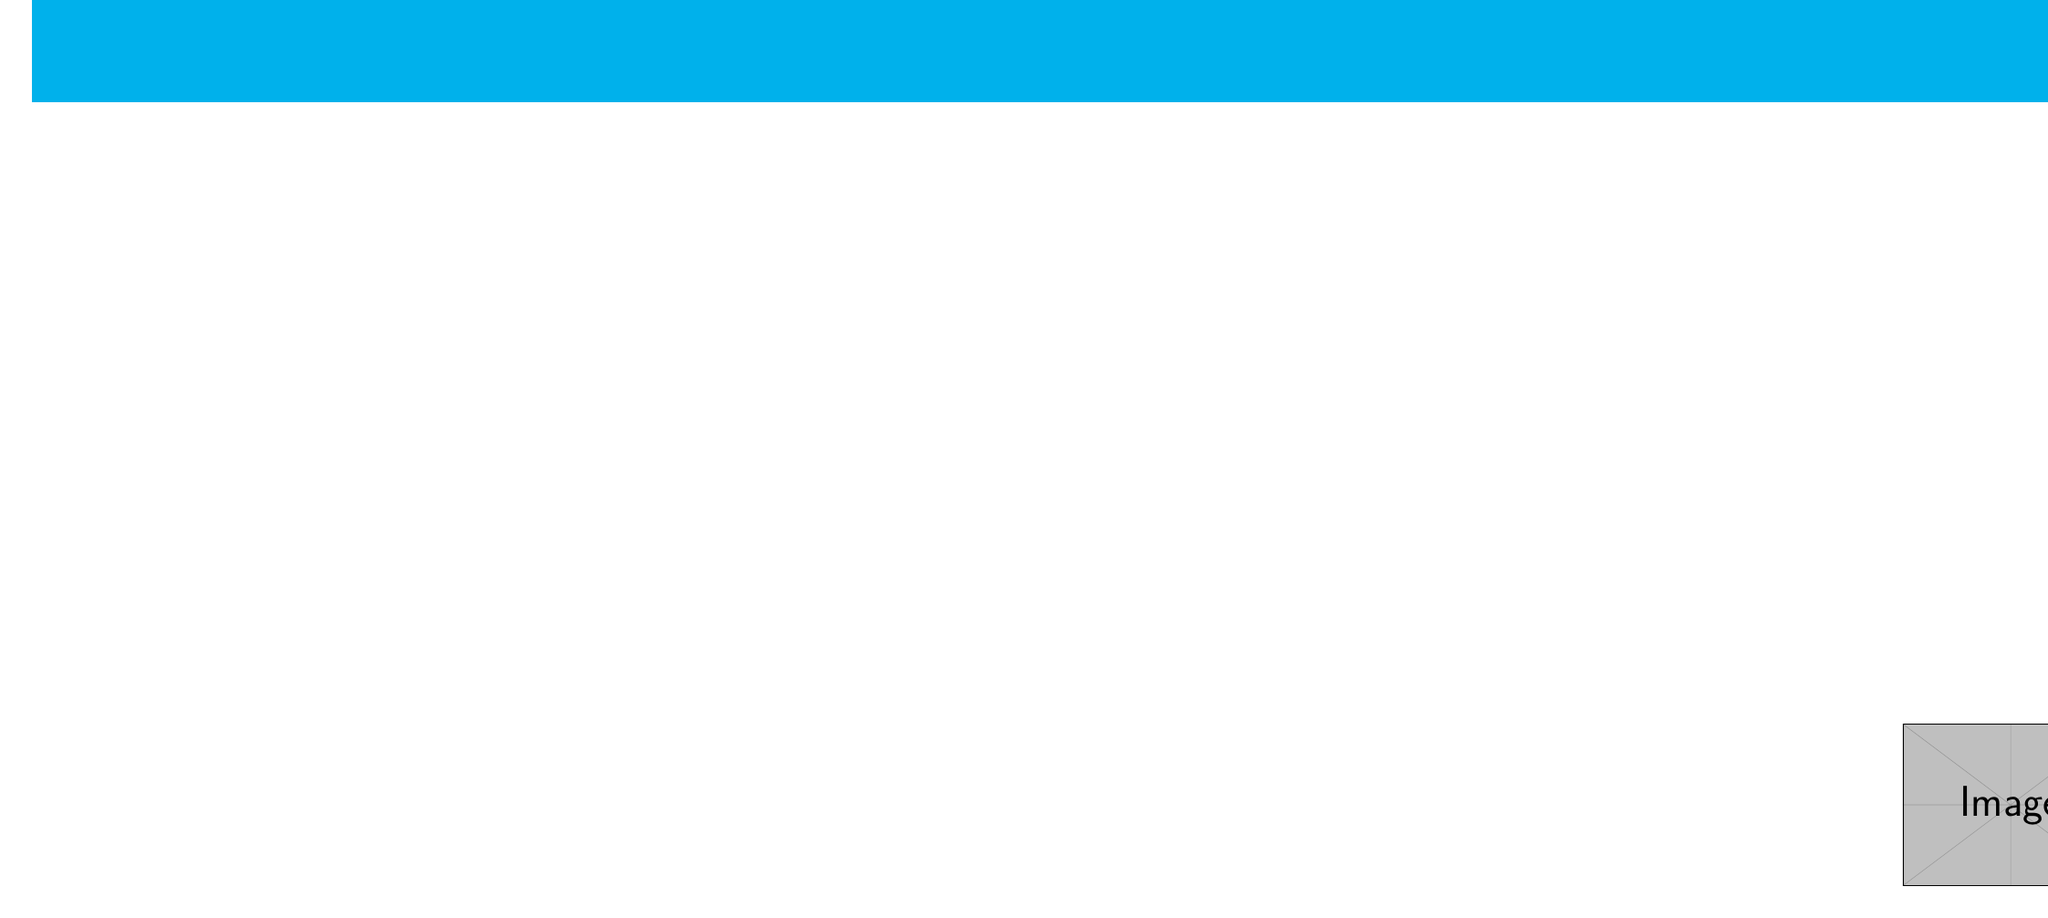What is the name of the exhibition featuring Guillermo del Toro? The document mentions an exhibition titled "Guillermo del Toro: Crafting Pinocchio".
Answer: Guillermo del Toro: Crafting Pinocchio When does the Cannes Spotlight Series occur? The Cannes Spotlight Series screenings are scheduled for the first Thursday of every month.
Answer: First Thursday of every month What special event involves a discussion with Sarah Polley? The document states there is an event called "In Conversation With: Sarah Polley."
Answer: In Conversation With: Sarah Polley How many free tickets do members receive annually? The membership benefits state members receive free tickets to over 200 screenings each year.
Answer: Over 200 What is the date for the Early Bird Festival Pass Sale? The Early Bird Festival Pass Sale is on April 1, 2024, as mentioned in the document.
Answer: April 1, 2024 For how long is the Guillermo del Toro exhibition open? The exhibition runs from September 15 to December 31, 2023, providing its duration.
Answer: September 15 - December 31, 2023 What is the contact email for TIFF Bell Lightbox? The document provides the email as customerrelations@tiff.net.
Answer: customerrelations@tiff.net On what day is the Canadian Cinema Showcase held? According to the document, the Canadian Cinema Showcase takes place every Wednesday.
Answer: Every Wednesday 